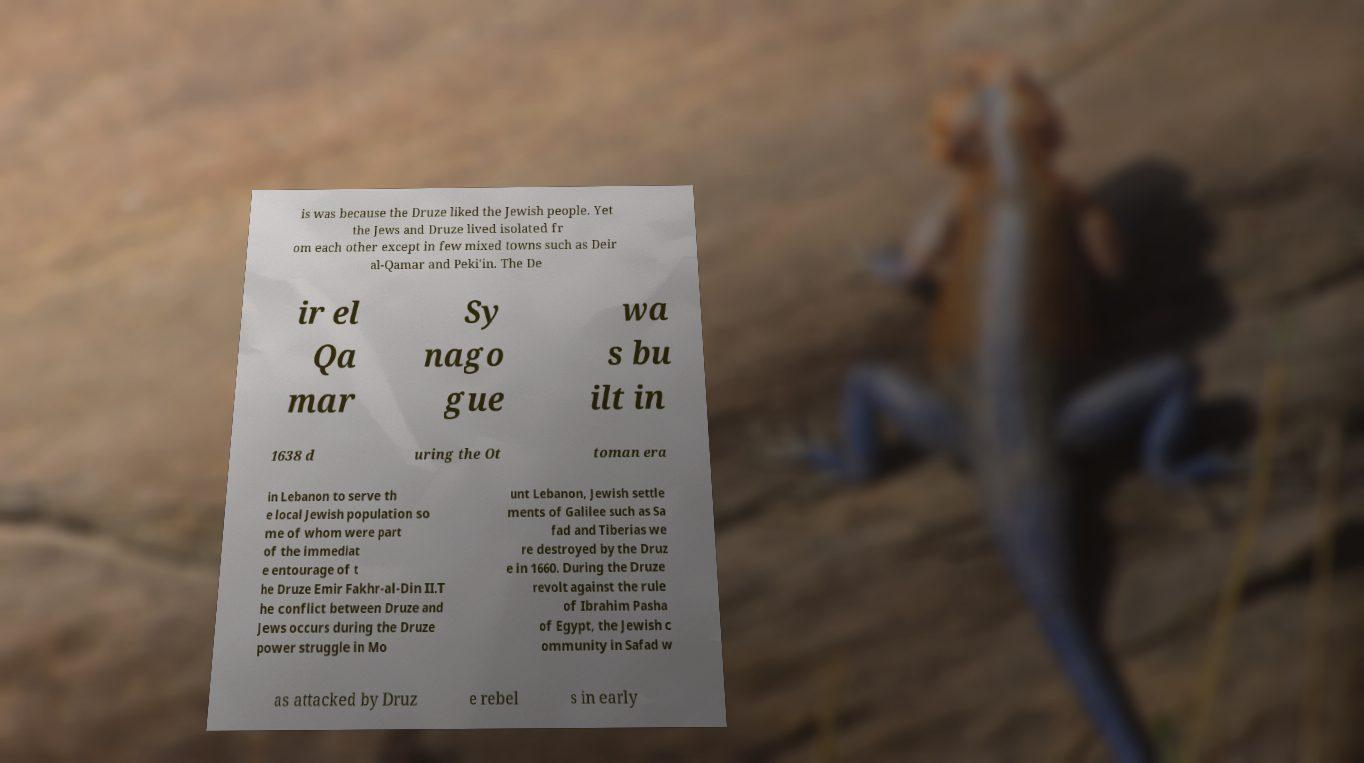Could you extract and type out the text from this image? is was because the Druze liked the Jewish people. Yet the Jews and Druze lived isolated fr om each other except in few mixed towns such as Deir al-Qamar and Peki'in. The De ir el Qa mar Sy nago gue wa s bu ilt in 1638 d uring the Ot toman era in Lebanon to serve th e local Jewish population so me of whom were part of the immediat e entourage of t he Druze Emir Fakhr-al-Din II.T he conflict between Druze and Jews occurs during the Druze power struggle in Mo unt Lebanon, Jewish settle ments of Galilee such as Sa fad and Tiberias we re destroyed by the Druz e in 1660. During the Druze revolt against the rule of Ibrahim Pasha of Egypt, the Jewish c ommunity in Safad w as attacked by Druz e rebel s in early 